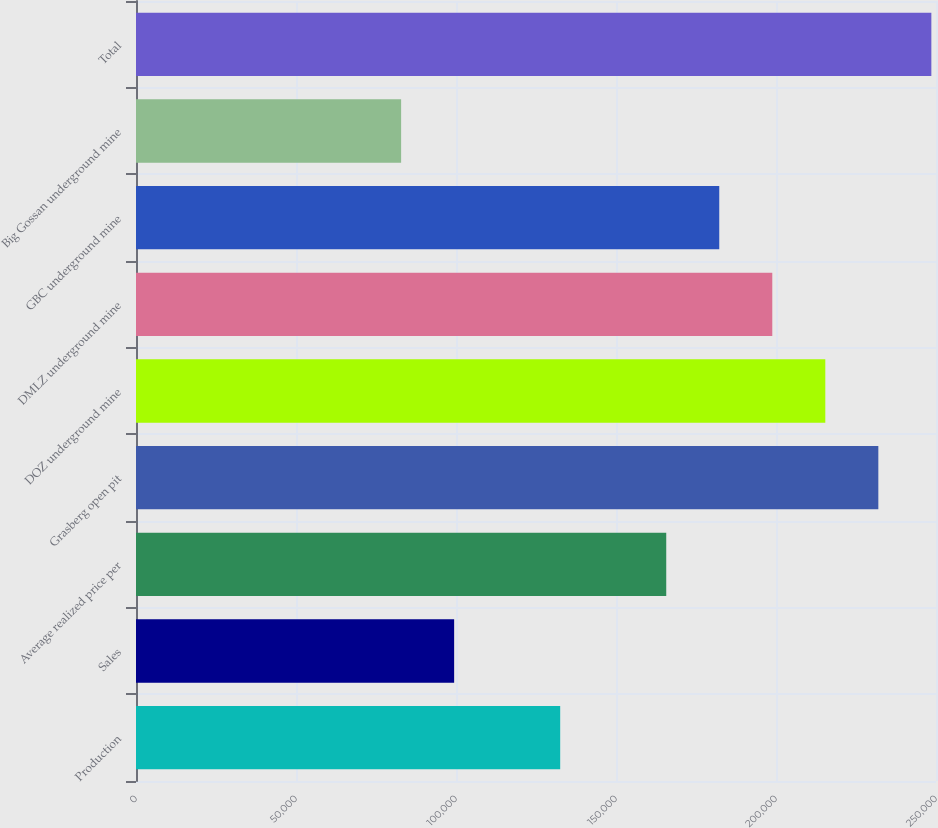Convert chart to OTSL. <chart><loc_0><loc_0><loc_500><loc_500><bar_chart><fcel>Production<fcel>Sales<fcel>Average realized price per<fcel>Grasberg open pit<fcel>DOZ underground mine<fcel>DMLZ underground mine<fcel>GBC underground mine<fcel>Big Gossan underground mine<fcel>Total<nl><fcel>132560<fcel>99420.3<fcel>165700<fcel>231980<fcel>215410<fcel>198840<fcel>182270<fcel>82850.3<fcel>248550<nl></chart> 